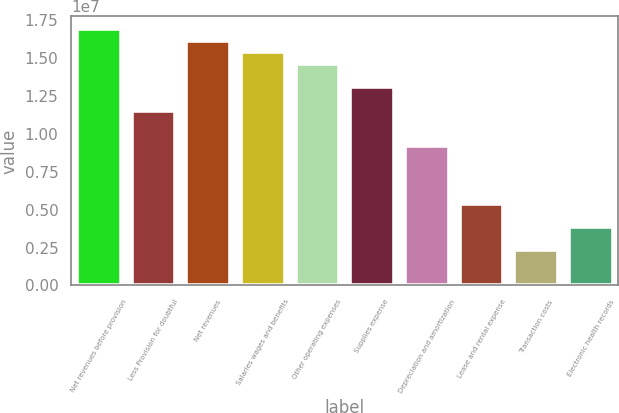Convert chart. <chart><loc_0><loc_0><loc_500><loc_500><bar_chart><fcel>Net revenues before provision<fcel>Less Provision for doubtful<fcel>Net revenues<fcel>Salaries wages and benefits<fcel>Other operating expenses<fcel>Supplies expense<fcel>Depreciation and amortization<fcel>Lease and rental expense<fcel>Transaction costs<fcel>Electronic health records<nl><fcel>1.69138e+07<fcel>1.15321e+07<fcel>1.61449e+07<fcel>1.53761e+07<fcel>1.46073e+07<fcel>1.30697e+07<fcel>9.22568e+06<fcel>5.38165e+06<fcel>2.30642e+06<fcel>3.84404e+06<nl></chart> 